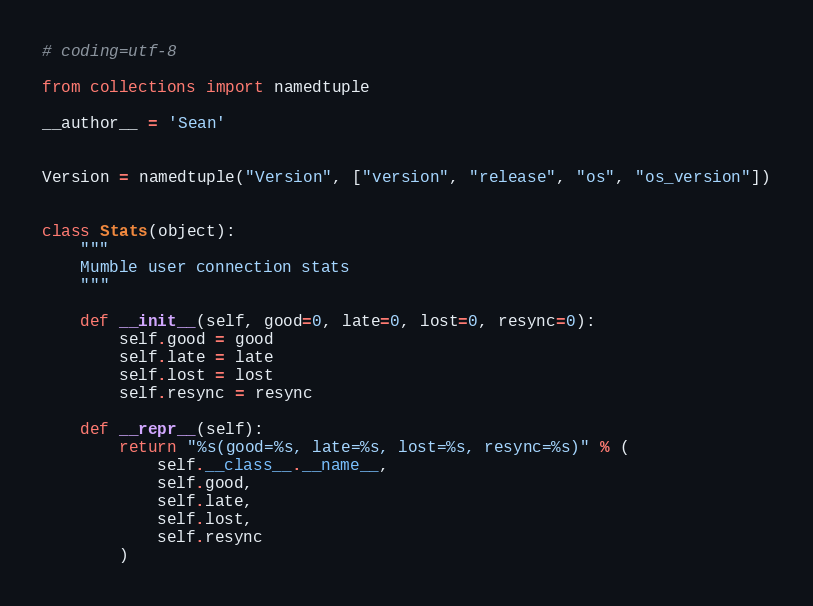Convert code to text. <code><loc_0><loc_0><loc_500><loc_500><_Python_># coding=utf-8

from collections import namedtuple

__author__ = 'Sean'


Version = namedtuple("Version", ["version", "release", "os", "os_version"])


class Stats(object):
    """
    Mumble user connection stats
    """

    def __init__(self, good=0, late=0, lost=0, resync=0):
        self.good = good
        self.late = late
        self.lost = lost
        self.resync = resync

    def __repr__(self):
        return "%s(good=%s, late=%s, lost=%s, resync=%s)" % (
            self.__class__.__name__,
            self.good,
            self.late,
            self.lost,
            self.resync
        )
</code> 